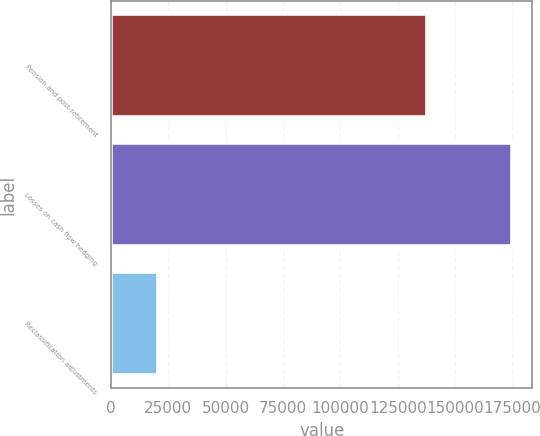Convert chart. <chart><loc_0><loc_0><loc_500><loc_500><bar_chart><fcel>Pension and post-retirement<fcel>Losses on cash flow hedging<fcel>Reclassification adjustments<nl><fcel>137918<fcel>175011<fcel>20282<nl></chart> 